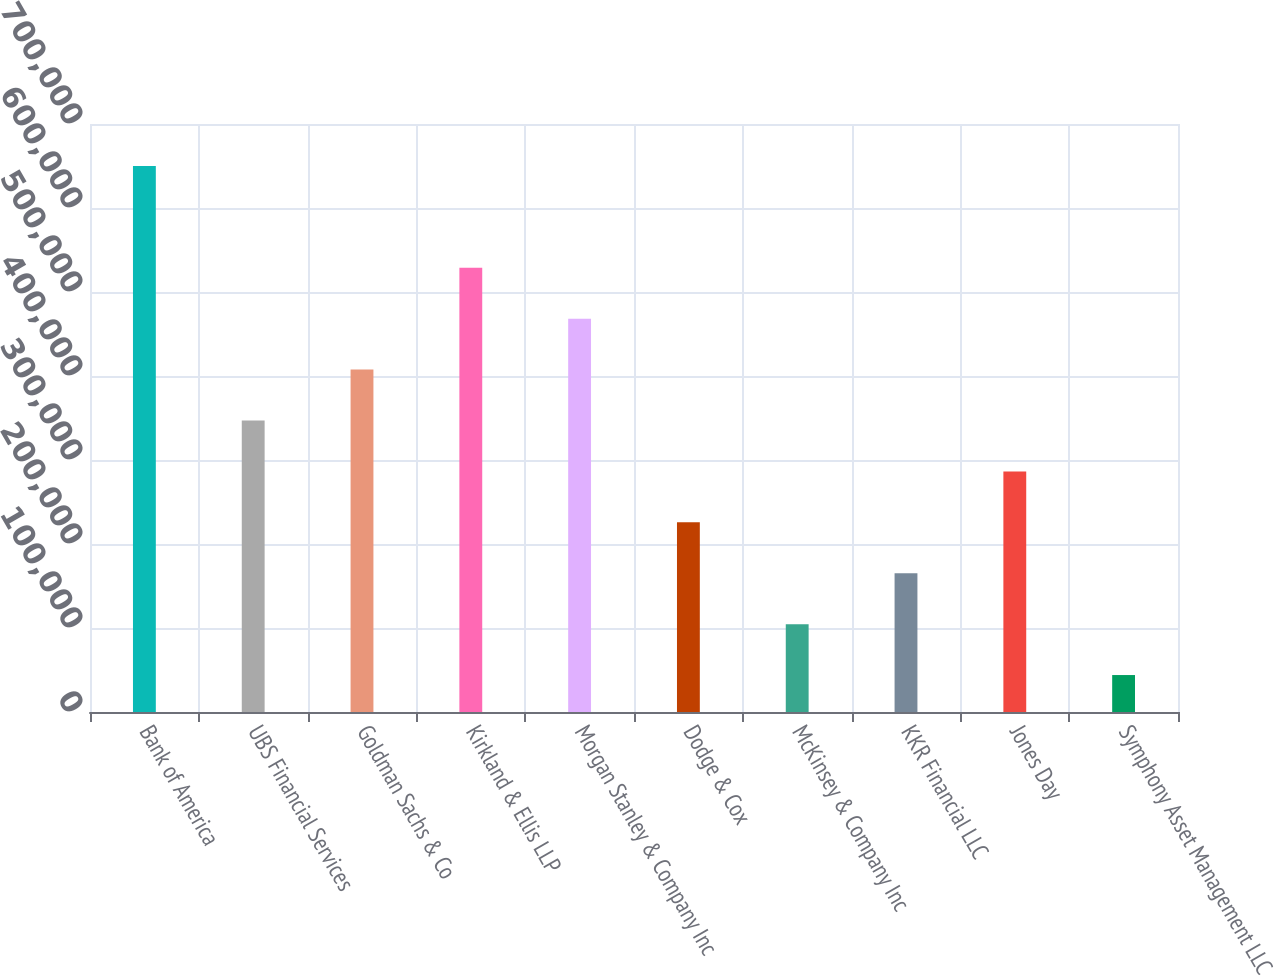Convert chart to OTSL. <chart><loc_0><loc_0><loc_500><loc_500><bar_chart><fcel>Bank of America<fcel>UBS Financial Services<fcel>Goldman Sachs & Co<fcel>Kirkland & Ellis LLP<fcel>Morgan Stanley & Company Inc<fcel>Dodge & Cox<fcel>McKinsey & Company Inc<fcel>KKR Financial LLC<fcel>Jones Day<fcel>Symphony Asset Management LLC<nl><fcel>650000<fcel>347000<fcel>407600<fcel>528800<fcel>468200<fcel>225800<fcel>104600<fcel>165200<fcel>286400<fcel>44000<nl></chart> 